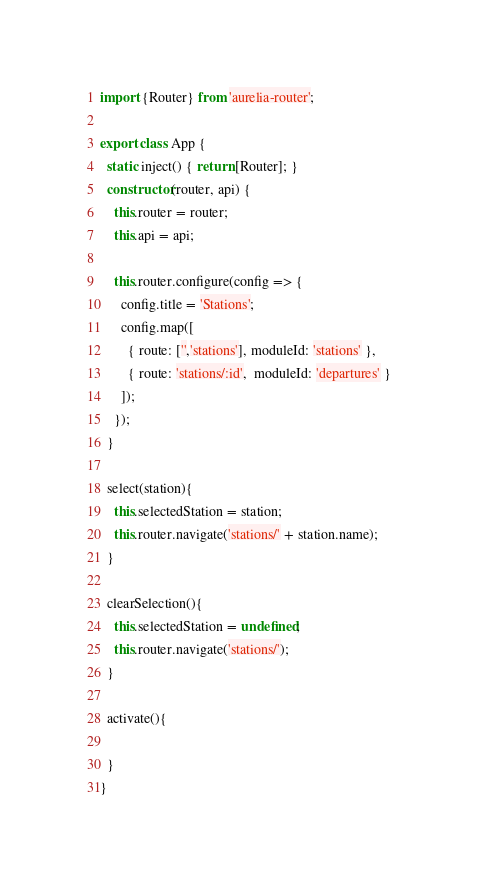Convert code to text. <code><loc_0><loc_0><loc_500><loc_500><_JavaScript_>import {Router} from 'aurelia-router';

export class App {
  static inject() { return [Router]; }
  constructor(router, api) {
    this.router = router;
    this.api = api;

    this.router.configure(config => {
      config.title = 'Stations';
      config.map([
        { route: ['','stations'], moduleId: 'stations' },
        { route: 'stations/:id',  moduleId: 'departures' }
      ]);
    });
  }

  select(station){
    this.selectedStation = station;
    this.router.navigate('stations/' + station.name);
  }

  clearSelection(){
    this.selectedStation = undefined;
    this.router.navigate('stations/');
  }

  activate(){

  }
}
</code> 